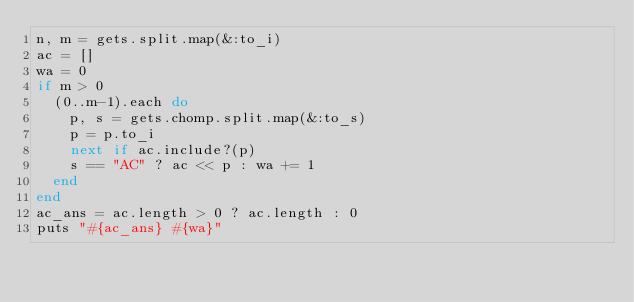<code> <loc_0><loc_0><loc_500><loc_500><_Ruby_>n, m = gets.split.map(&:to_i)
ac = []
wa = 0
if m > 0
  (0..m-1).each do
    p, s = gets.chomp.split.map(&:to_s)
    p = p.to_i
    next if ac.include?(p)
    s == "AC" ? ac << p : wa += 1
  end
end
ac_ans = ac.length > 0 ? ac.length : 0
puts "#{ac_ans} #{wa}"
</code> 